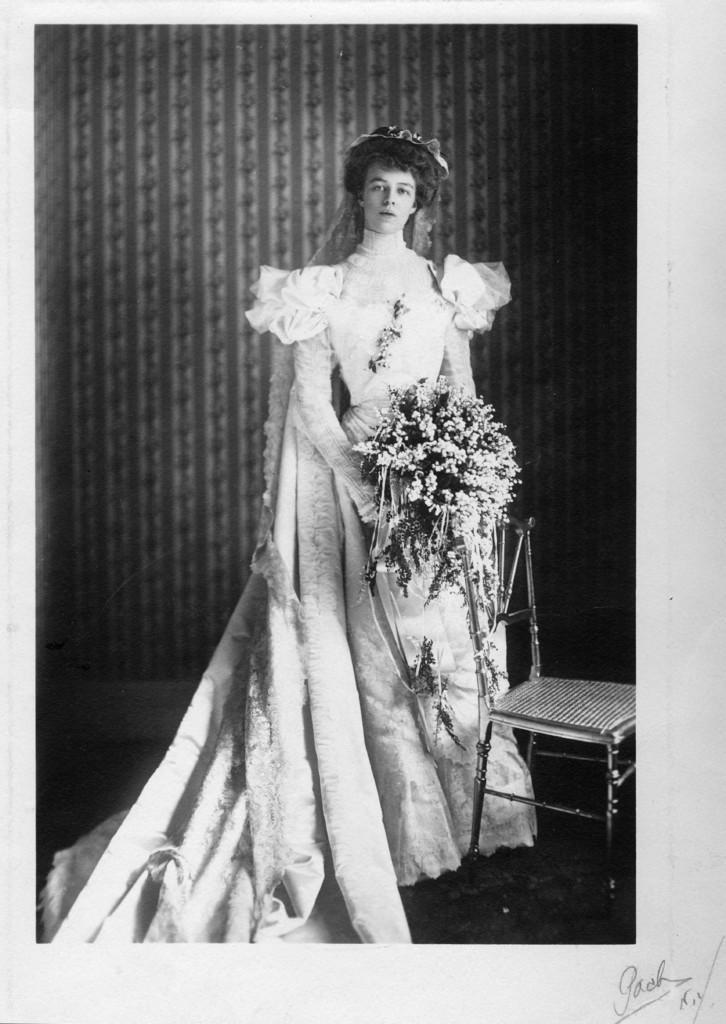In one or two sentences, can you explain what this image depicts? This is a black and white image. In the center of the image there is a lady wearing a white color dress and she is holding a bouquet in her hand. At the right side of the image there is a chair. 